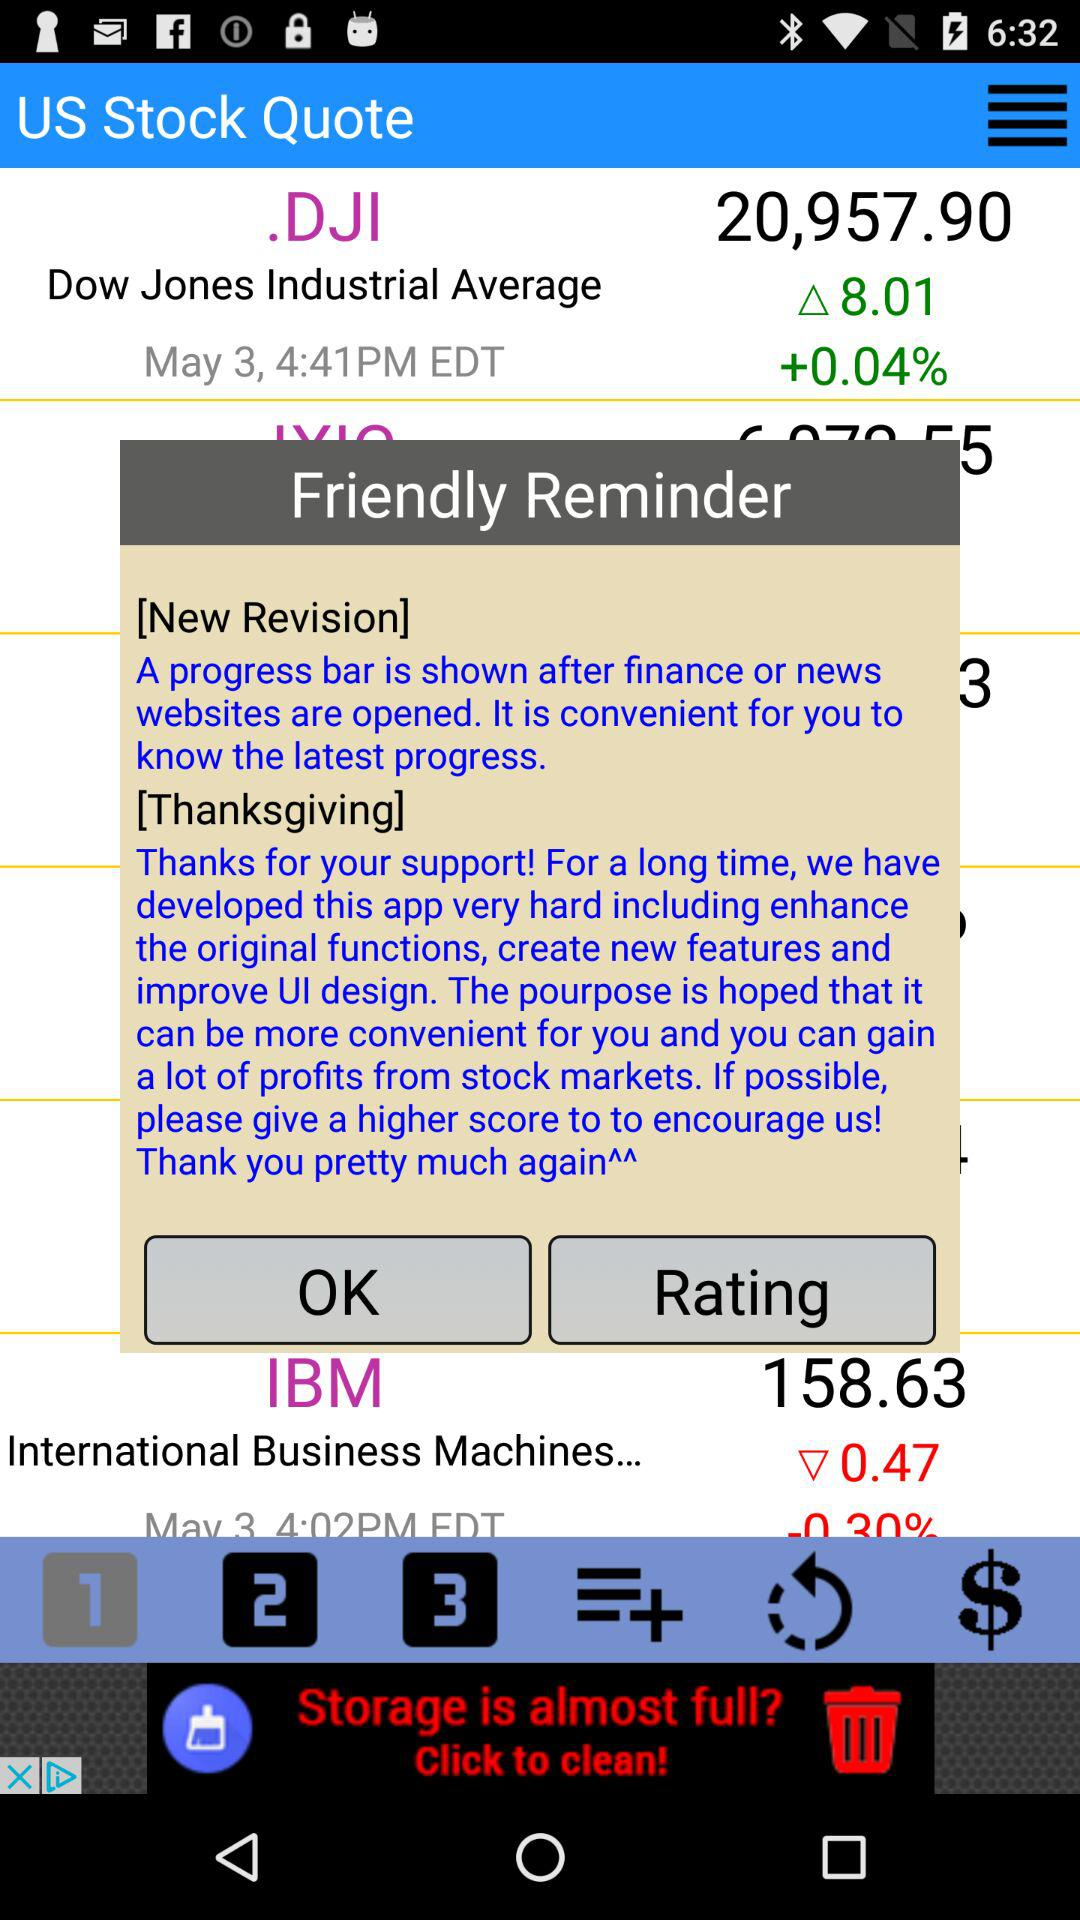How much has the value of.DJI stock increased? The value of.DJI stock increased by 8.01. 